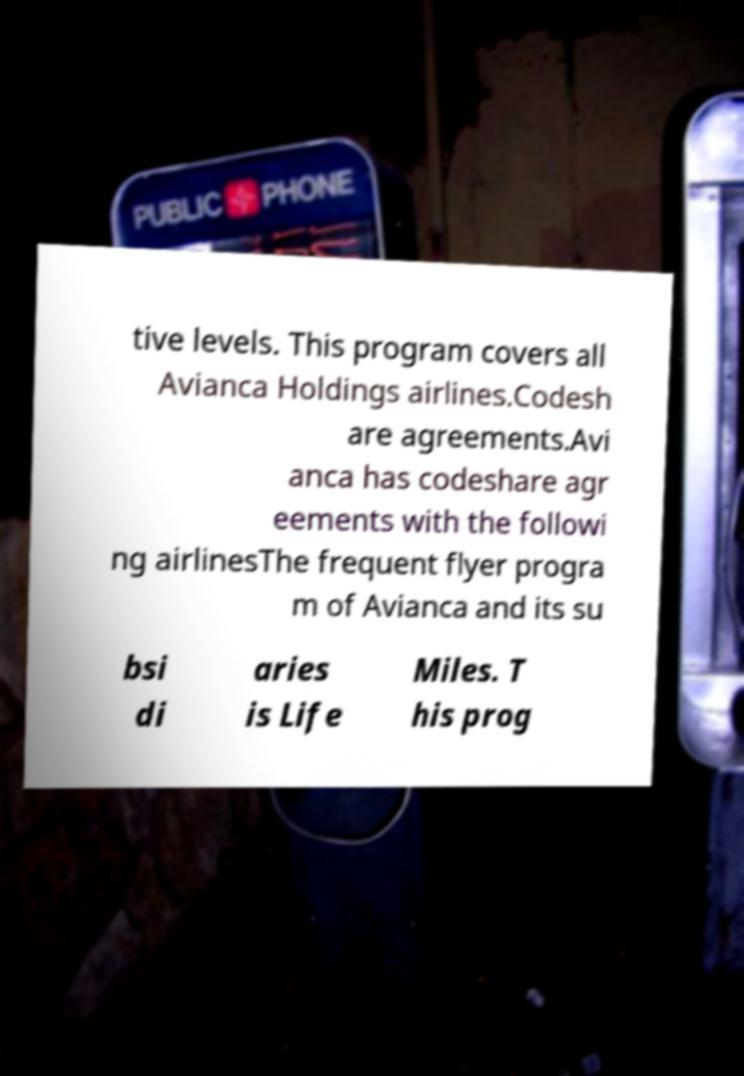I need the written content from this picture converted into text. Can you do that? tive levels. This program covers all Avianca Holdings airlines.Codesh are agreements.Avi anca has codeshare agr eements with the followi ng airlinesThe frequent flyer progra m of Avianca and its su bsi di aries is Life Miles. T his prog 